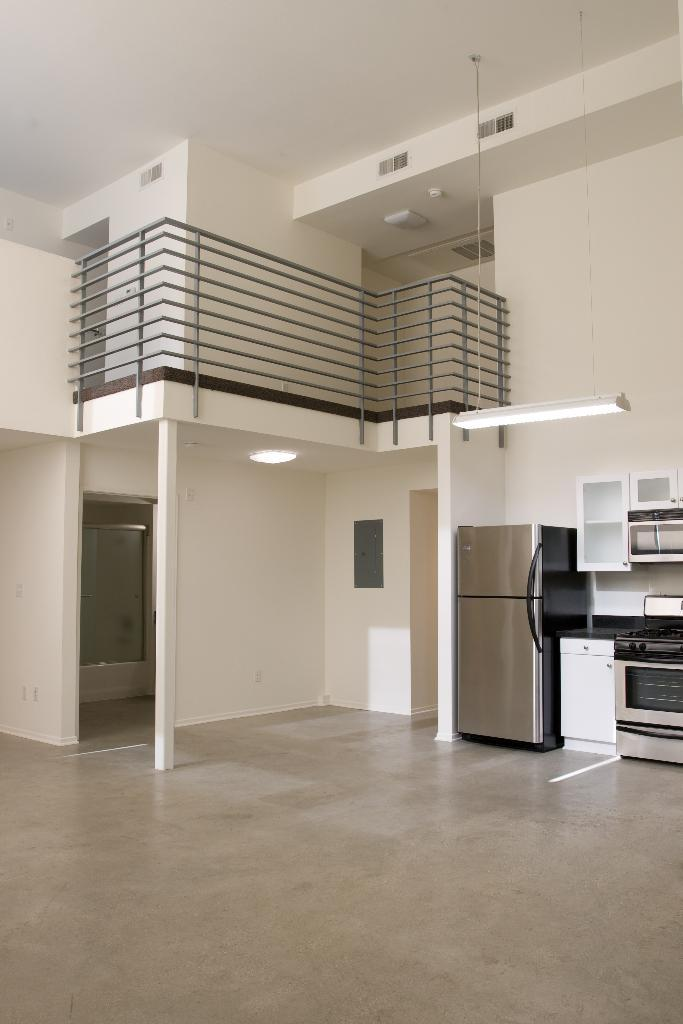What type of location is depicted in the image? The image shows an inside view of a building. What appliances can be seen in the image? There is a refrigerator and an oven in the image. What can be used for illumination in the image? There are lights visible in the image. What material is used for the rods in the image? Metal rods are present in the image. What type of flowers are growing on the moon in the image? There is no mention of flowers or the moon in the image; it shows an inside view of a building with appliances and metal rods. 